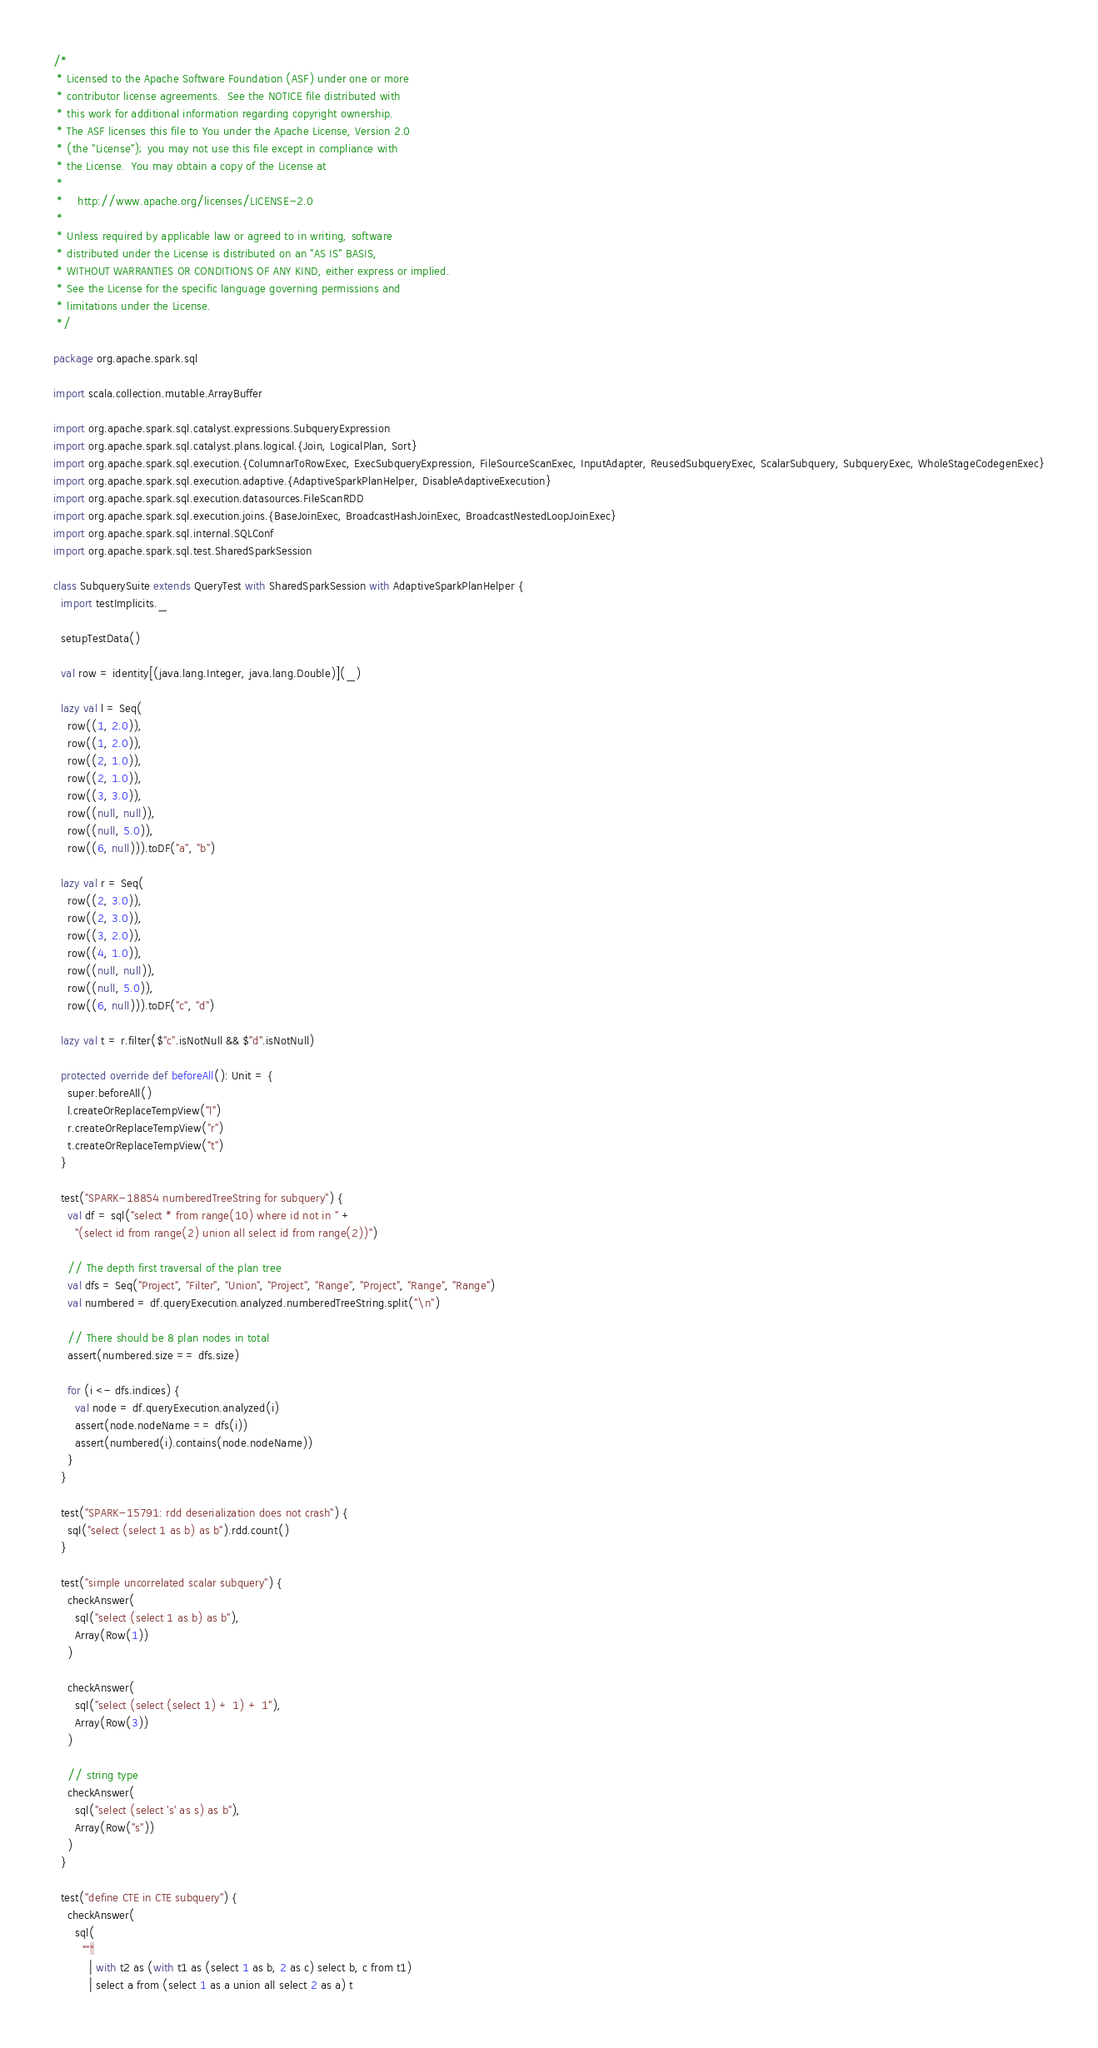Convert code to text. <code><loc_0><loc_0><loc_500><loc_500><_Scala_>/*
 * Licensed to the Apache Software Foundation (ASF) under one or more
 * contributor license agreements.  See the NOTICE file distributed with
 * this work for additional information regarding copyright ownership.
 * The ASF licenses this file to You under the Apache License, Version 2.0
 * (the "License"); you may not use this file except in compliance with
 * the License.  You may obtain a copy of the License at
 *
 *    http://www.apache.org/licenses/LICENSE-2.0
 *
 * Unless required by applicable law or agreed to in writing, software
 * distributed under the License is distributed on an "AS IS" BASIS,
 * WITHOUT WARRANTIES OR CONDITIONS OF ANY KIND, either express or implied.
 * See the License for the specific language governing permissions and
 * limitations under the License.
 */

package org.apache.spark.sql

import scala.collection.mutable.ArrayBuffer

import org.apache.spark.sql.catalyst.expressions.SubqueryExpression
import org.apache.spark.sql.catalyst.plans.logical.{Join, LogicalPlan, Sort}
import org.apache.spark.sql.execution.{ColumnarToRowExec, ExecSubqueryExpression, FileSourceScanExec, InputAdapter, ReusedSubqueryExec, ScalarSubquery, SubqueryExec, WholeStageCodegenExec}
import org.apache.spark.sql.execution.adaptive.{AdaptiveSparkPlanHelper, DisableAdaptiveExecution}
import org.apache.spark.sql.execution.datasources.FileScanRDD
import org.apache.spark.sql.execution.joins.{BaseJoinExec, BroadcastHashJoinExec, BroadcastNestedLoopJoinExec}
import org.apache.spark.sql.internal.SQLConf
import org.apache.spark.sql.test.SharedSparkSession

class SubquerySuite extends QueryTest with SharedSparkSession with AdaptiveSparkPlanHelper {
  import testImplicits._

  setupTestData()

  val row = identity[(java.lang.Integer, java.lang.Double)](_)

  lazy val l = Seq(
    row((1, 2.0)),
    row((1, 2.0)),
    row((2, 1.0)),
    row((2, 1.0)),
    row((3, 3.0)),
    row((null, null)),
    row((null, 5.0)),
    row((6, null))).toDF("a", "b")

  lazy val r = Seq(
    row((2, 3.0)),
    row((2, 3.0)),
    row((3, 2.0)),
    row((4, 1.0)),
    row((null, null)),
    row((null, 5.0)),
    row((6, null))).toDF("c", "d")

  lazy val t = r.filter($"c".isNotNull && $"d".isNotNull)

  protected override def beforeAll(): Unit = {
    super.beforeAll()
    l.createOrReplaceTempView("l")
    r.createOrReplaceTempView("r")
    t.createOrReplaceTempView("t")
  }

  test("SPARK-18854 numberedTreeString for subquery") {
    val df = sql("select * from range(10) where id not in " +
      "(select id from range(2) union all select id from range(2))")

    // The depth first traversal of the plan tree
    val dfs = Seq("Project", "Filter", "Union", "Project", "Range", "Project", "Range", "Range")
    val numbered = df.queryExecution.analyzed.numberedTreeString.split("\n")

    // There should be 8 plan nodes in total
    assert(numbered.size == dfs.size)

    for (i <- dfs.indices) {
      val node = df.queryExecution.analyzed(i)
      assert(node.nodeName == dfs(i))
      assert(numbered(i).contains(node.nodeName))
    }
  }

  test("SPARK-15791: rdd deserialization does not crash") {
    sql("select (select 1 as b) as b").rdd.count()
  }

  test("simple uncorrelated scalar subquery") {
    checkAnswer(
      sql("select (select 1 as b) as b"),
      Array(Row(1))
    )

    checkAnswer(
      sql("select (select (select 1) + 1) + 1"),
      Array(Row(3))
    )

    // string type
    checkAnswer(
      sql("select (select 's' as s) as b"),
      Array(Row("s"))
    )
  }

  test("define CTE in CTE subquery") {
    checkAnswer(
      sql(
        """
          | with t2 as (with t1 as (select 1 as b, 2 as c) select b, c from t1)
          | select a from (select 1 as a union all select 2 as a) t</code> 